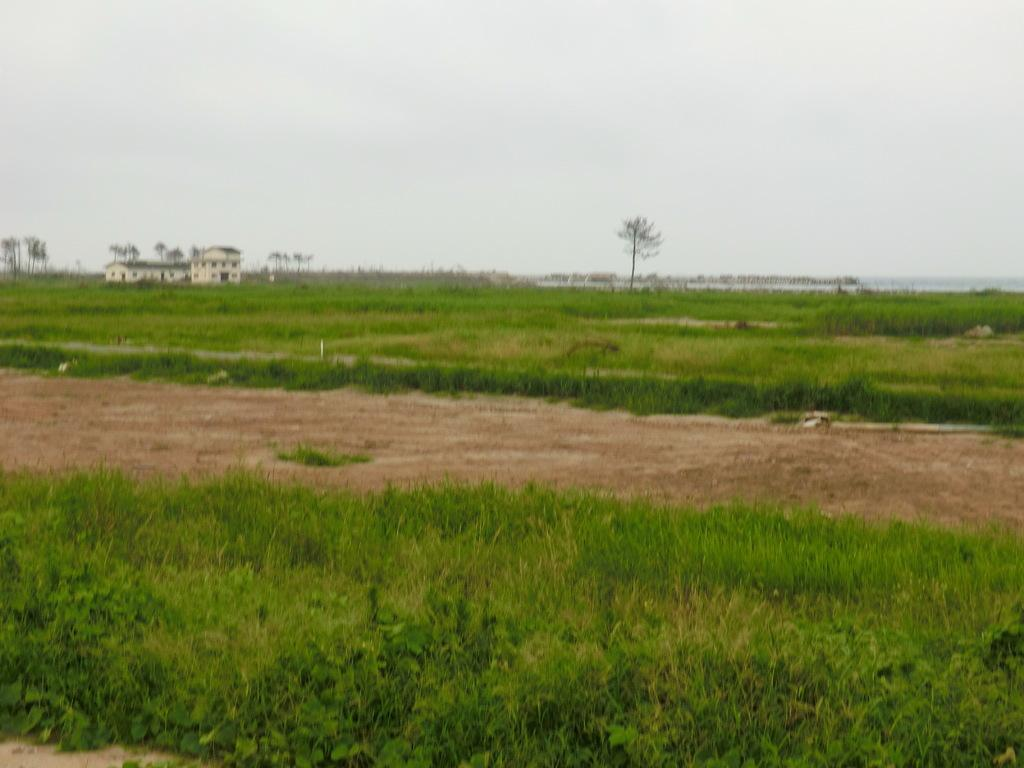What type of vegetation can be seen in the image? There are many plants in the image, including grass. What part of the natural environment is visible at the bottom of the image? The ground is visible at the bottom of the image. What can be seen in the background of the image? There is a building in the background of the image. What is visible at the top of the image? The sky is visible at the top of the image. Can you tell me how many goats are grazing on the grass in the image? There are no goats present in the image; it features plants and grass. What type of pleasure can be derived from the image? The image does not convey a specific pleasure or emotion; it is a visual representation of plants, grass, ground, a building, and the sky. 